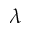<formula> <loc_0><loc_0><loc_500><loc_500>\lambda</formula> 